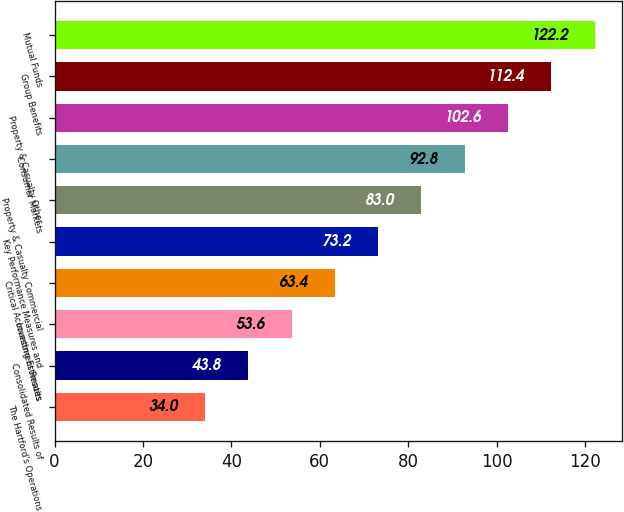Convert chart to OTSL. <chart><loc_0><loc_0><loc_500><loc_500><bar_chart><fcel>The Hartford's Operations<fcel>Consolidated Results of<fcel>Investment Results<fcel>Critical Accounting Estimates<fcel>Key Performance Measures and<fcel>Property & Casualty Commercial<fcel>Consumer Markets<fcel>Property & Casualty Other<fcel>Group Benefits<fcel>Mutual Funds<nl><fcel>34<fcel>43.8<fcel>53.6<fcel>63.4<fcel>73.2<fcel>83<fcel>92.8<fcel>102.6<fcel>112.4<fcel>122.2<nl></chart> 